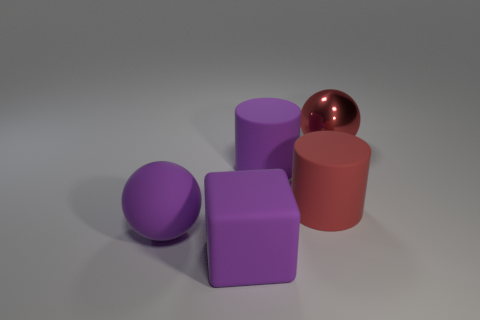Add 3 tiny red rubber balls. How many objects exist? 8 Subtract all cylinders. How many objects are left? 3 Subtract all cylinders. Subtract all purple rubber cylinders. How many objects are left? 2 Add 3 large purple matte cylinders. How many large purple matte cylinders are left? 4 Add 4 tiny brown metallic cylinders. How many tiny brown metallic cylinders exist? 4 Subtract 0 cyan cylinders. How many objects are left? 5 